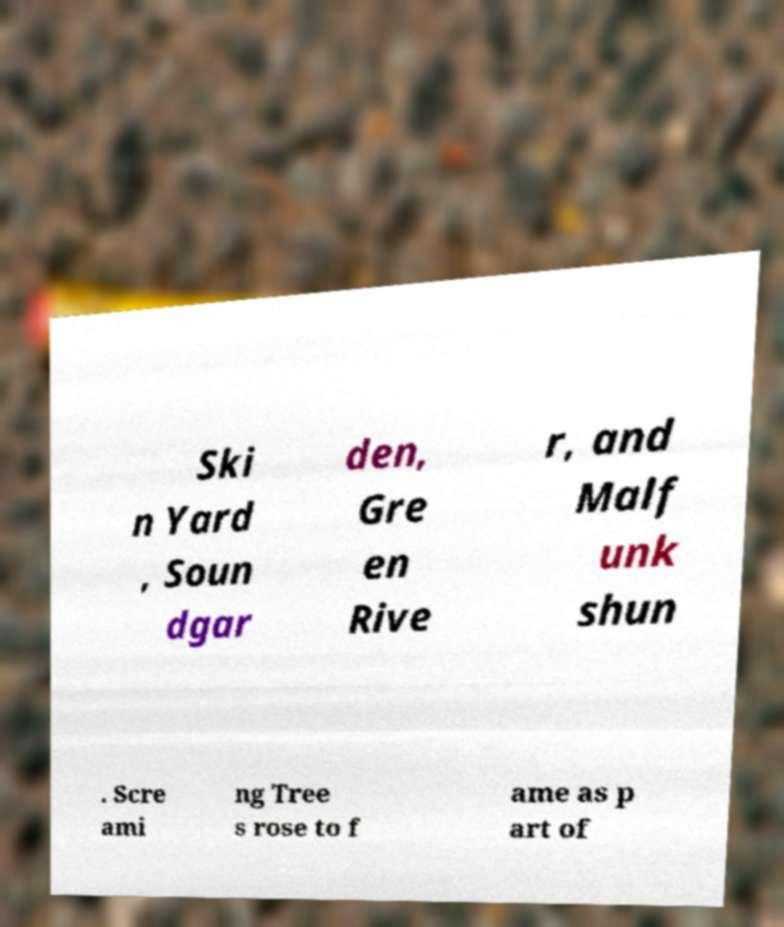Can you read and provide the text displayed in the image?This photo seems to have some interesting text. Can you extract and type it out for me? Ski n Yard , Soun dgar den, Gre en Rive r, and Malf unk shun . Scre ami ng Tree s rose to f ame as p art of 